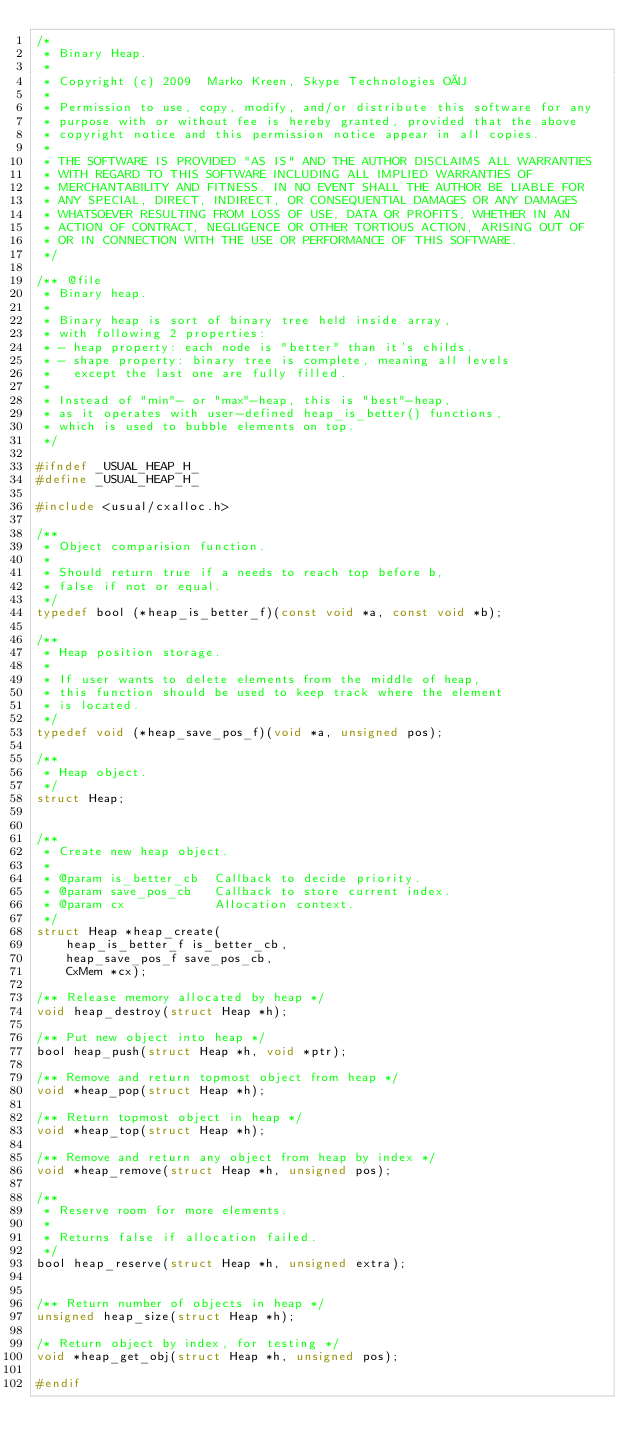<code> <loc_0><loc_0><loc_500><loc_500><_C_>/*
 * Binary Heap.
 *
 * Copyright (c) 2009  Marko Kreen, Skype Technologies OÜ
 *
 * Permission to use, copy, modify, and/or distribute this software for any
 * purpose with or without fee is hereby granted, provided that the above
 * copyright notice and this permission notice appear in all copies.
 *
 * THE SOFTWARE IS PROVIDED "AS IS" AND THE AUTHOR DISCLAIMS ALL WARRANTIES
 * WITH REGARD TO THIS SOFTWARE INCLUDING ALL IMPLIED WARRANTIES OF
 * MERCHANTABILITY AND FITNESS. IN NO EVENT SHALL THE AUTHOR BE LIABLE FOR
 * ANY SPECIAL, DIRECT, INDIRECT, OR CONSEQUENTIAL DAMAGES OR ANY DAMAGES
 * WHATSOEVER RESULTING FROM LOSS OF USE, DATA OR PROFITS, WHETHER IN AN
 * ACTION OF CONTRACT, NEGLIGENCE OR OTHER TORTIOUS ACTION, ARISING OUT OF
 * OR IN CONNECTION WITH THE USE OR PERFORMANCE OF THIS SOFTWARE.
 */

/** @file
 * Binary heap.
 *
 * Binary heap is sort of binary tree held inside array,
 * with following 2 properties:
 * - heap property: each node is "better" than it's childs.
 * - shape property: binary tree is complete, meaning all levels
 *   except the last one are fully filled.
 *
 * Instead of "min"- or "max"-heap, this is "best"-heap,
 * as it operates with user-defined heap_is_better() functions,
 * which is used to bubble elements on top.
 */

#ifndef _USUAL_HEAP_H_
#define _USUAL_HEAP_H_

#include <usual/cxalloc.h>

/**
 * Object comparision function.
 *
 * Should return true if a needs to reach top before b,
 * false if not or equal.
 */
typedef bool (*heap_is_better_f)(const void *a, const void *b);

/**
 * Heap position storage.
 *
 * If user wants to delete elements from the middle of heap,
 * this function should be used to keep track where the element
 * is located.
 */
typedef void (*heap_save_pos_f)(void *a, unsigned pos);

/**
 * Heap object.
 */
struct Heap;


/**
 * Create new heap object.
 *
 * @param is_better_cb  Callback to decide priority.
 * @param save_pos_cb   Callback to store current index.
 * @param cx            Allocation context.
 */
struct Heap *heap_create(
	heap_is_better_f is_better_cb,
	heap_save_pos_f save_pos_cb,
	CxMem *cx);

/** Release memory allocated by heap */
void heap_destroy(struct Heap *h);

/** Put new object into heap */
bool heap_push(struct Heap *h, void *ptr);

/** Remove and return topmost object from heap */
void *heap_pop(struct Heap *h);

/** Return topmost object in heap */
void *heap_top(struct Heap *h);

/** Remove and return any object from heap by index */
void *heap_remove(struct Heap *h, unsigned pos);

/**
 * Reserve room for more elements.
 *
 * Returns false if allocation failed.
 */
bool heap_reserve(struct Heap *h, unsigned extra);


/** Return number of objects in heap */
unsigned heap_size(struct Heap *h);

/* Return object by index, for testing */
void *heap_get_obj(struct Heap *h, unsigned pos);

#endif

</code> 